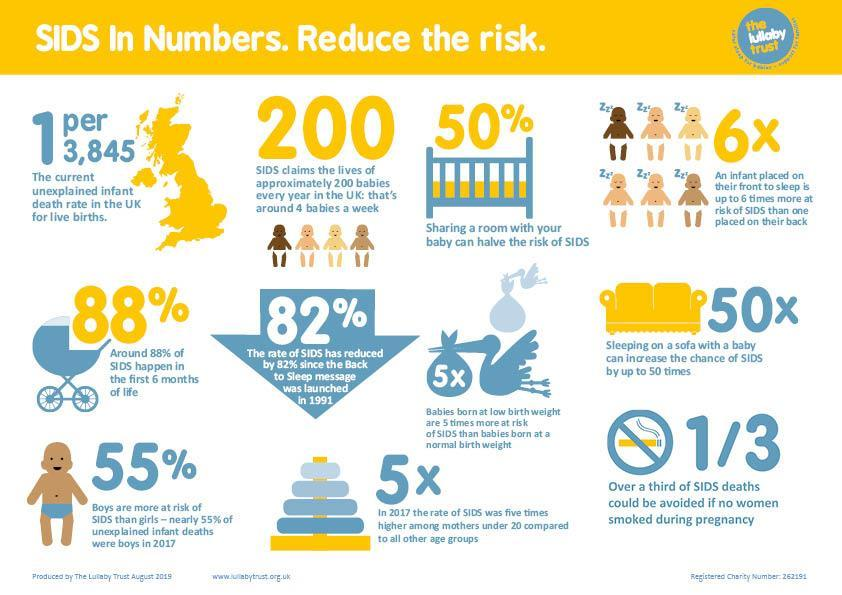What is the current unexplained infant death rate in the UK for live births?
Answer the question with a short phrase. 1 per 3,845 What is the decrease in the rate of SIDS since the back to sleep message was launched in UK in 1991? 82% What percentage of SIDS happen in the first 6 months in UK? around 88% How many baby lives were claimed due to SIDS each year in the UK? approximately 200 babies What is the percentage decrease in risk of SIDS if sharing a room with the baby? 50% 